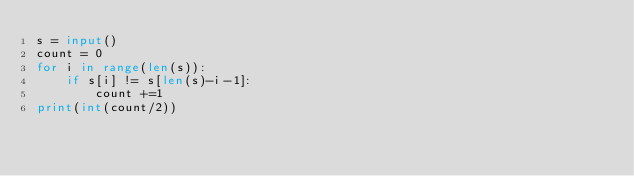Convert code to text. <code><loc_0><loc_0><loc_500><loc_500><_Python_>s = input()
count = 0
for i in range(len(s)):
    if s[i] != s[len(s)-i-1]:
        count +=1
print(int(count/2))
</code> 